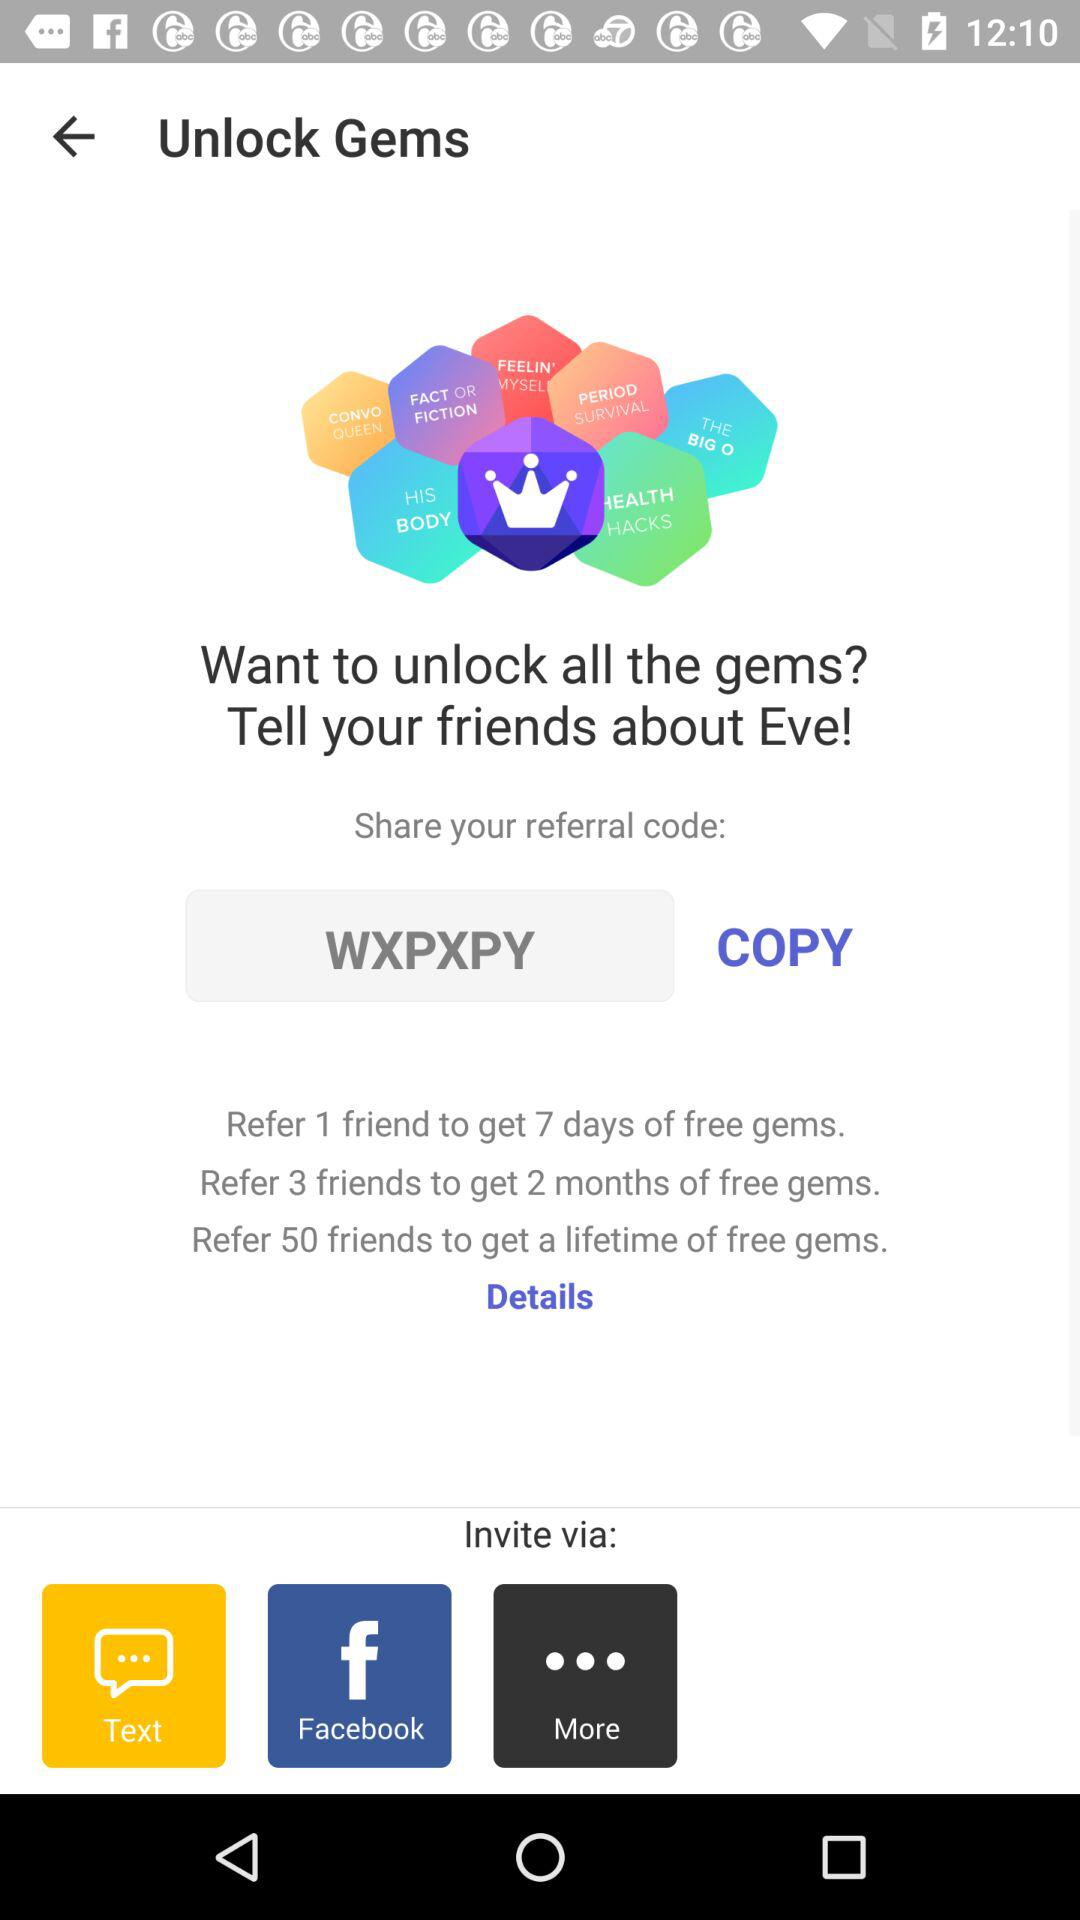What is the referral code? The referral code is "WXPXPY". 